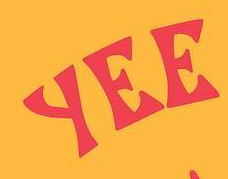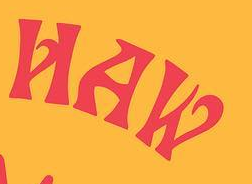Transcribe the words shown in these images in order, separated by a semicolon. YEE; HAW 